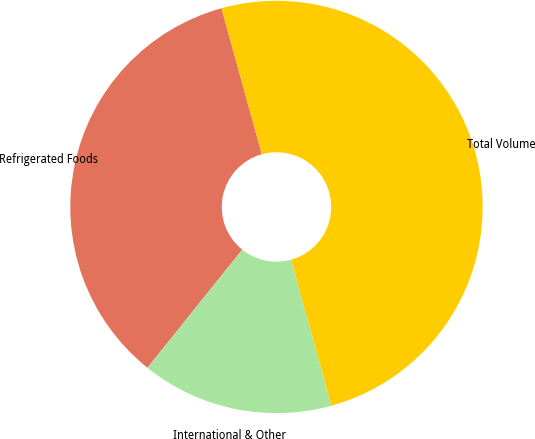<chart> <loc_0><loc_0><loc_500><loc_500><pie_chart><fcel>Refrigerated Foods<fcel>International & Other<fcel>Total Volume<nl><fcel>34.94%<fcel>15.06%<fcel>50.0%<nl></chart> 